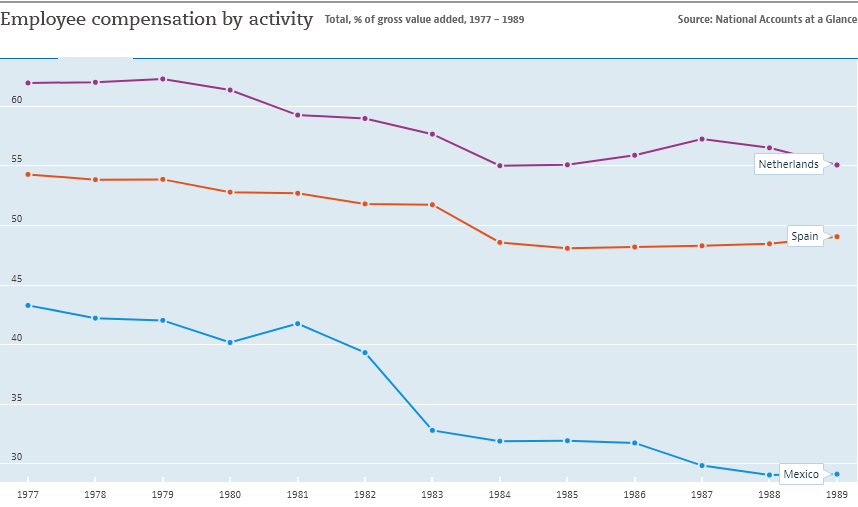Identify some key points in this picture. The Netherlands is represented by the violet color line in the graph. In 1977, there was a significant increase in employee compensation activity in Mexico. 